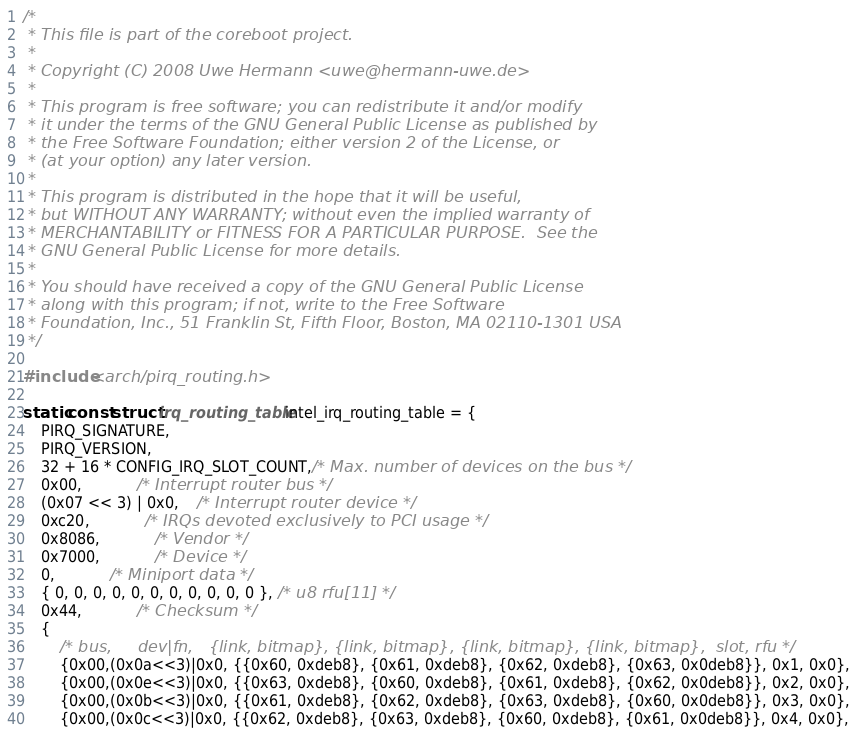<code> <loc_0><loc_0><loc_500><loc_500><_C_>/*
 * This file is part of the coreboot project.
 *
 * Copyright (C) 2008 Uwe Hermann <uwe@hermann-uwe.de>
 *
 * This program is free software; you can redistribute it and/or modify
 * it under the terms of the GNU General Public License as published by
 * the Free Software Foundation; either version 2 of the License, or
 * (at your option) any later version.
 *
 * This program is distributed in the hope that it will be useful,
 * but WITHOUT ANY WARRANTY; without even the implied warranty of
 * MERCHANTABILITY or FITNESS FOR A PARTICULAR PURPOSE.  See the
 * GNU General Public License for more details.
 *
 * You should have received a copy of the GNU General Public License
 * along with this program; if not, write to the Free Software
 * Foundation, Inc., 51 Franklin St, Fifth Floor, Boston, MA 02110-1301 USA
 */

#include <arch/pirq_routing.h>

static const struct irq_routing_table intel_irq_routing_table = {
	PIRQ_SIGNATURE,
	PIRQ_VERSION,
	32 + 16 * CONFIG_IRQ_SLOT_COUNT,/* Max. number of devices on the bus */
	0x00,			/* Interrupt router bus */
	(0x07 << 3) | 0x0,	/* Interrupt router device */
	0xc20,			/* IRQs devoted exclusively to PCI usage */
	0x8086,			/* Vendor */
	0x7000,			/* Device */
	0,			/* Miniport data */
	{ 0, 0, 0, 0, 0, 0, 0, 0, 0, 0, 0 }, /* u8 rfu[11] */
	0x44,			/* Checksum */
	{
		/* bus,     dev|fn,   {link, bitmap}, {link, bitmap}, {link, bitmap}, {link, bitmap},  slot, rfu */
		{0x00,(0x0a<<3)|0x0, {{0x60, 0xdeb8}, {0x61, 0xdeb8}, {0x62, 0xdeb8}, {0x63, 0x0deb8}}, 0x1, 0x0},
		{0x00,(0x0e<<3)|0x0, {{0x63, 0xdeb8}, {0x60, 0xdeb8}, {0x61, 0xdeb8}, {0x62, 0x0deb8}}, 0x2, 0x0},
		{0x00,(0x0b<<3)|0x0, {{0x61, 0xdeb8}, {0x62, 0xdeb8}, {0x63, 0xdeb8}, {0x60, 0x0deb8}}, 0x3, 0x0},
		{0x00,(0x0c<<3)|0x0, {{0x62, 0xdeb8}, {0x63, 0xdeb8}, {0x60, 0xdeb8}, {0x61, 0x0deb8}}, 0x4, 0x0},</code> 